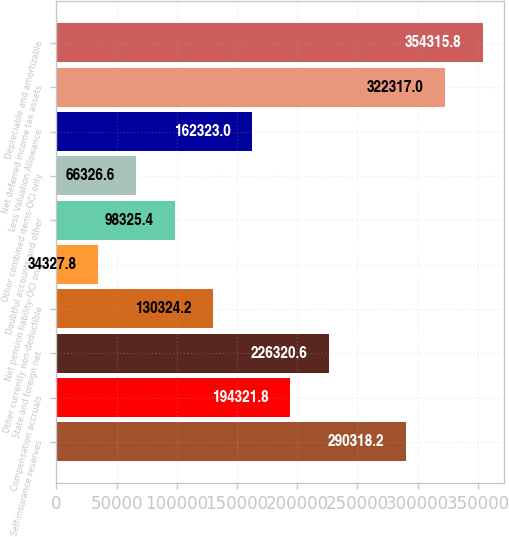Convert chart to OTSL. <chart><loc_0><loc_0><loc_500><loc_500><bar_chart><fcel>Self-insurance reserves<fcel>Compensation accruals<fcel>State and foreign net<fcel>Other currently non-deductible<fcel>Net pension liability-OCI only<fcel>Doubtful accounts and other<fcel>Other combined items-OCI only<fcel>Less Valuation Allowance<fcel>Net deferred income tax assets<fcel>Depreciable and amortizable<nl><fcel>290318<fcel>194322<fcel>226321<fcel>130324<fcel>34327.8<fcel>98325.4<fcel>66326.6<fcel>162323<fcel>322317<fcel>354316<nl></chart> 